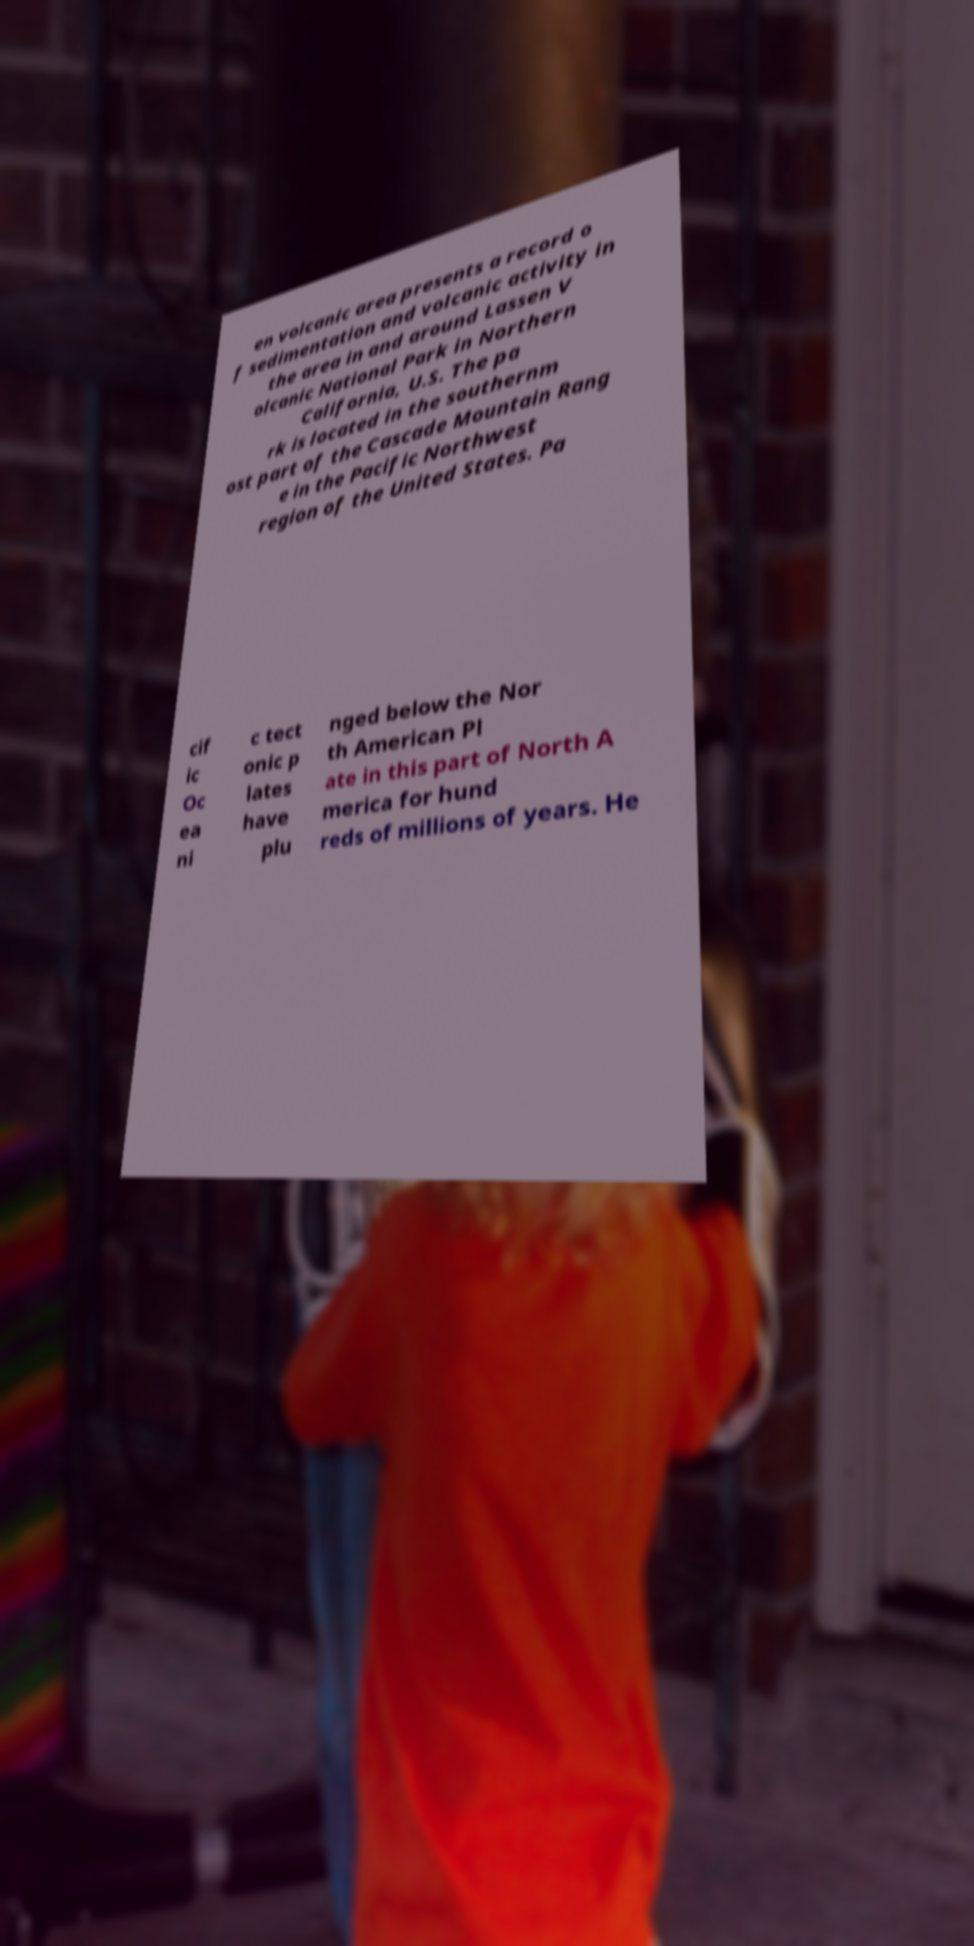Can you accurately transcribe the text from the provided image for me? en volcanic area presents a record o f sedimentation and volcanic activity in the area in and around Lassen V olcanic National Park in Northern California, U.S. The pa rk is located in the southernm ost part of the Cascade Mountain Rang e in the Pacific Northwest region of the United States. Pa cif ic Oc ea ni c tect onic p lates have plu nged below the Nor th American Pl ate in this part of North A merica for hund reds of millions of years. He 